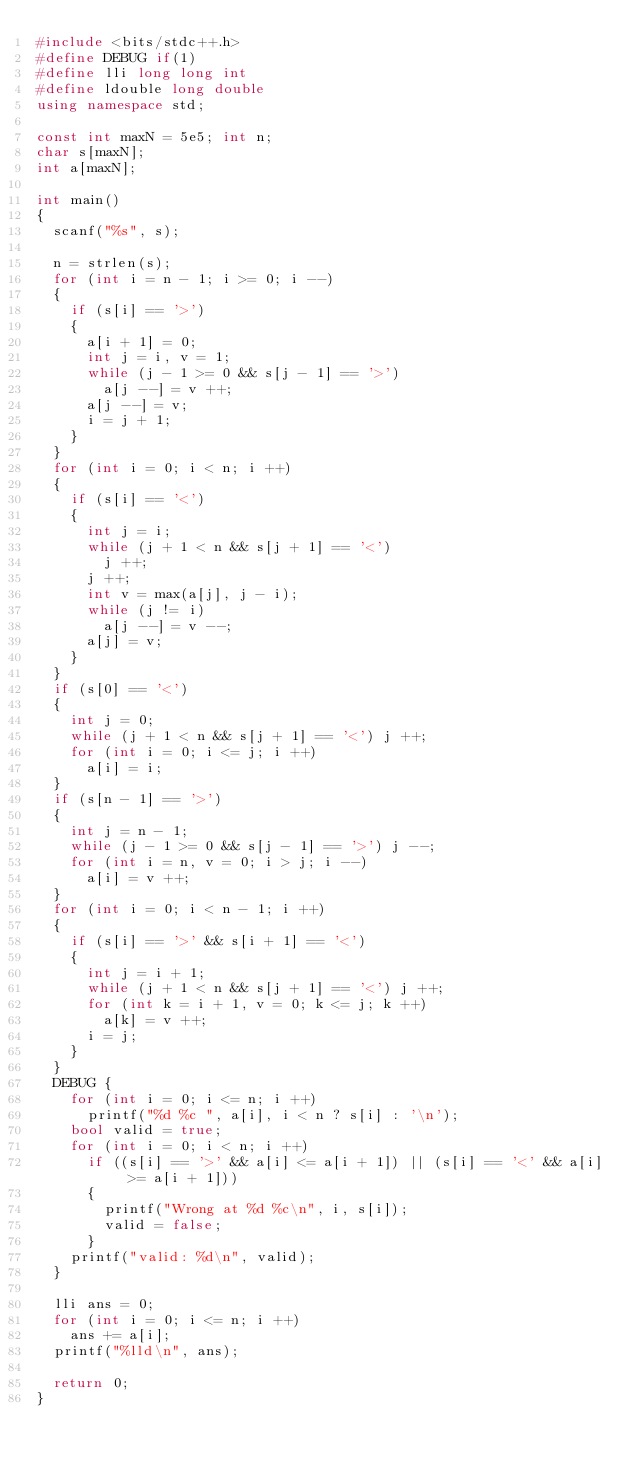Convert code to text. <code><loc_0><loc_0><loc_500><loc_500><_C++_>#include <bits/stdc++.h>
#define DEBUG if(1)
#define lli long long int
#define ldouble long double
using namespace std;

const int maxN = 5e5; int n;
char s[maxN];
int a[maxN];

int main()
{
  scanf("%s", s);

  n = strlen(s);
  for (int i = n - 1; i >= 0; i --)
  {
    if (s[i] == '>')
    {
      a[i + 1] = 0;
      int j = i, v = 1;
      while (j - 1 >= 0 && s[j - 1] == '>')
        a[j --] = v ++;
      a[j --] = v;
      i = j + 1;
    }
  }
  for (int i = 0; i < n; i ++)
  {
    if (s[i] == '<')
    {
      int j = i;
      while (j + 1 < n && s[j + 1] == '<')
        j ++;
      j ++;
      int v = max(a[j], j - i);
      while (j != i)
        a[j --] = v --;
      a[j] = v;
    }
  }
  if (s[0] == '<')
  {
    int j = 0;
    while (j + 1 < n && s[j + 1] == '<') j ++;
    for (int i = 0; i <= j; i ++)
      a[i] = i;
  }
  if (s[n - 1] == '>')
  {
    int j = n - 1;
    while (j - 1 >= 0 && s[j - 1] == '>') j --;
    for (int i = n, v = 0; i > j; i --)
      a[i] = v ++;
  }
  for (int i = 0; i < n - 1; i ++)
  {
    if (s[i] == '>' && s[i + 1] == '<')
    {
      int j = i + 1;
      while (j + 1 < n && s[j + 1] == '<') j ++;
      for (int k = i + 1, v = 0; k <= j; k ++)
        a[k] = v ++;
      i = j;
    }
  }
  DEBUG {
    for (int i = 0; i <= n; i ++)
      printf("%d %c ", a[i], i < n ? s[i] : '\n');
    bool valid = true;
    for (int i = 0; i < n; i ++)
      if ((s[i] == '>' && a[i] <= a[i + 1]) || (s[i] == '<' && a[i] >= a[i + 1]))
      {
        printf("Wrong at %d %c\n", i, s[i]);
        valid = false;
      }
    printf("valid: %d\n", valid);
  }

  lli ans = 0;
  for (int i = 0; i <= n; i ++)
    ans += a[i];
  printf("%lld\n", ans);

  return 0;
}</code> 